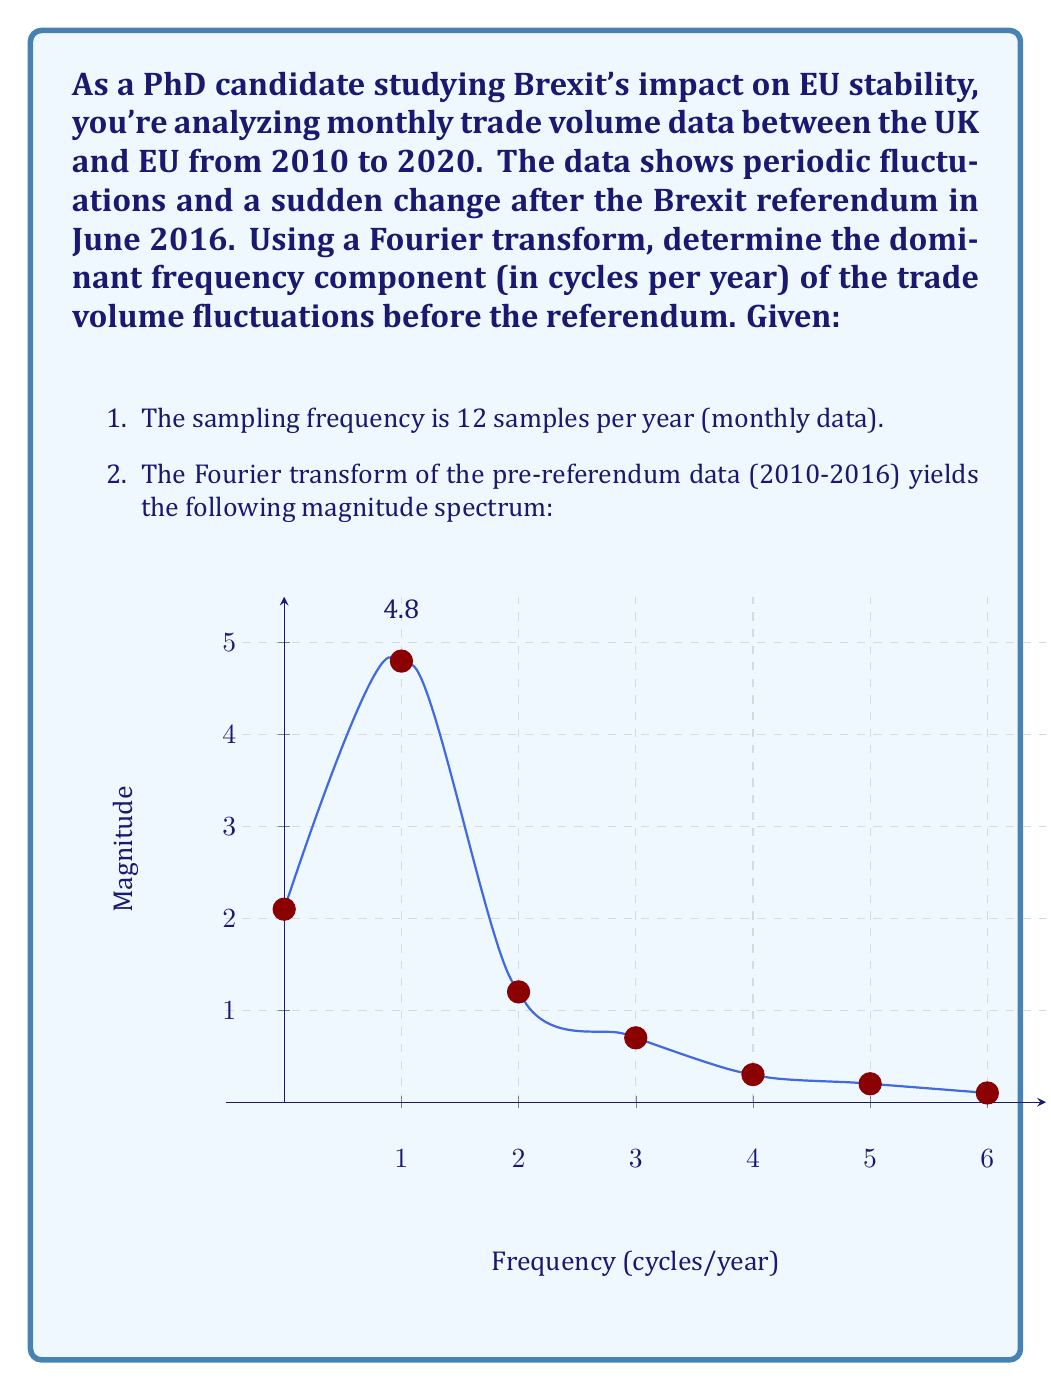What is the answer to this math problem? To solve this problem, we'll follow these steps:

1) Recall that for a discrete Fourier transform of N samples, the frequency resolution is given by:

   $$\Delta f = \frac{f_s}{N}$$

   where $f_s$ is the sampling frequency.

2) In this case, $f_s = 12$ samples/year, and we're given the spectrum up to 6 cycles/year, which corresponds to half the sampling frequency (Nyquist frequency).

3) The magnitude spectrum shows peaks at different frequencies. The dominant frequency is the one with the highest magnitude.

4) From the graph, we can see that the highest magnitude (4.8) occurs at 1 cycle/year.

5) To confirm this is indeed 1 cycle/year, we can check that the x-axis values correspond to integers from 0 to 6, representing frequencies in cycles/year.

6) The dominant frequency of 1 cycle/year indicates that the trade volume has a strong annual periodicity, which makes sense in the context of yearly economic cycles affecting trade.

This analysis reveals that before the Brexit referendum, the UK-EU trade volume had a strong yearly cycle, which could be due to factors such as fiscal years, annual budgets, or seasonal trade patterns.
Answer: 1 cycle/year 